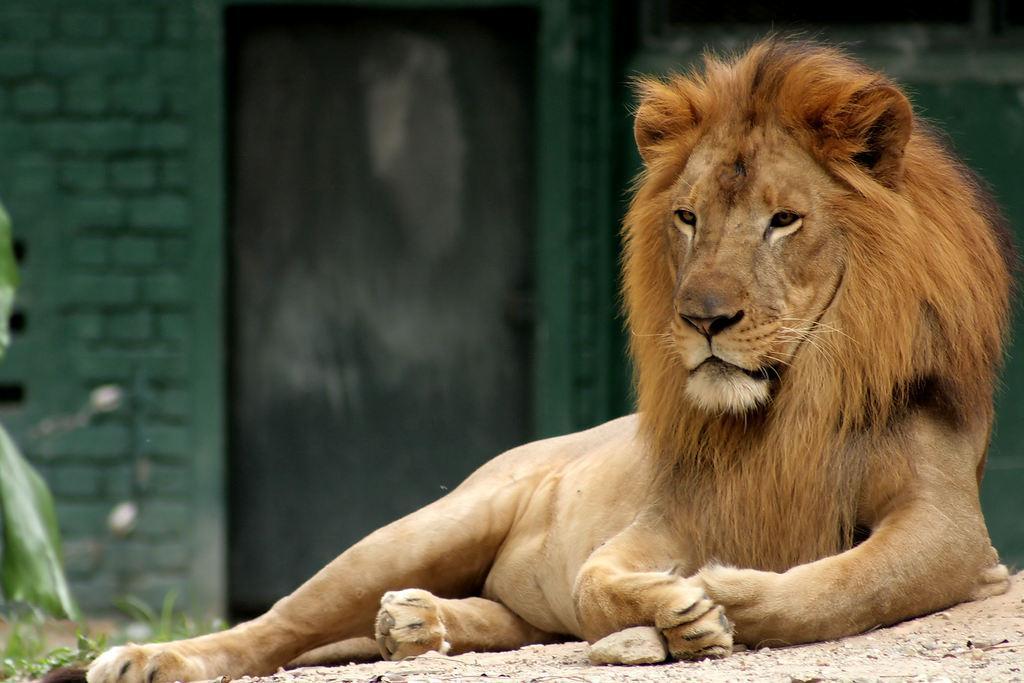Can you describe this image briefly? Here we can see a lion sitting on the ground. In the background there is a door and wall. On the left side there is a plant. 